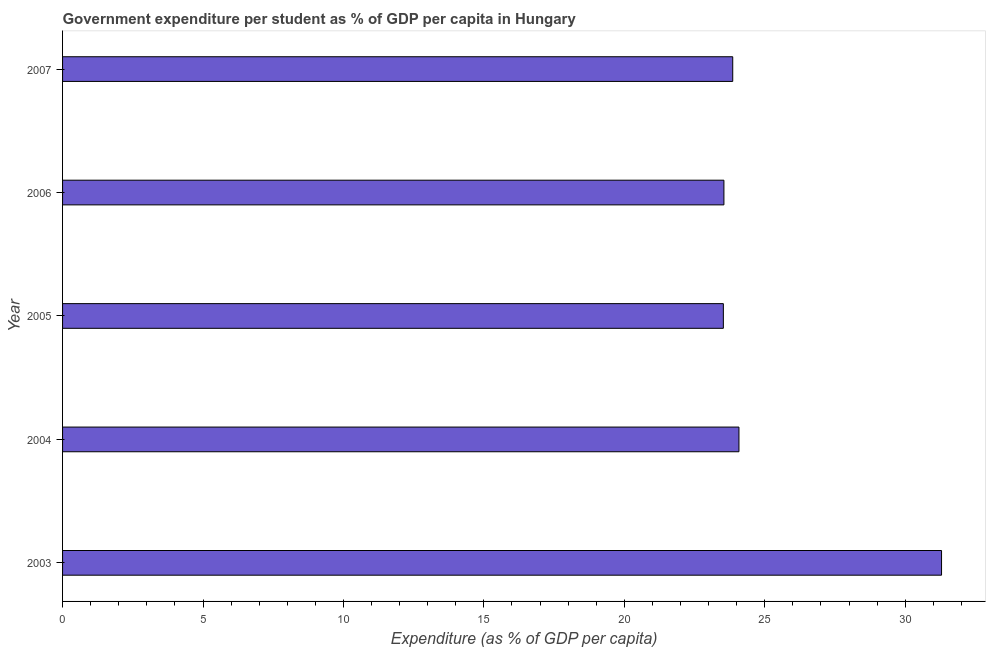What is the title of the graph?
Your answer should be compact. Government expenditure per student as % of GDP per capita in Hungary. What is the label or title of the X-axis?
Your answer should be very brief. Expenditure (as % of GDP per capita). What is the label or title of the Y-axis?
Offer a very short reply. Year. What is the government expenditure per student in 2004?
Provide a succinct answer. 24.08. Across all years, what is the maximum government expenditure per student?
Your answer should be compact. 31.29. Across all years, what is the minimum government expenditure per student?
Offer a terse response. 23.53. What is the sum of the government expenditure per student?
Offer a terse response. 126.3. What is the difference between the government expenditure per student in 2003 and 2006?
Your answer should be compact. 7.75. What is the average government expenditure per student per year?
Your answer should be compact. 25.26. What is the median government expenditure per student?
Your answer should be very brief. 23.86. In how many years, is the government expenditure per student greater than 4 %?
Make the answer very short. 5. Do a majority of the years between 2004 and 2005 (inclusive) have government expenditure per student greater than 20 %?
Provide a succinct answer. Yes. Is the government expenditure per student in 2003 less than that in 2006?
Ensure brevity in your answer.  No. What is the difference between the highest and the second highest government expenditure per student?
Provide a succinct answer. 7.21. What is the difference between the highest and the lowest government expenditure per student?
Provide a short and direct response. 7.77. How many bars are there?
Provide a short and direct response. 5. Are all the bars in the graph horizontal?
Provide a succinct answer. Yes. Are the values on the major ticks of X-axis written in scientific E-notation?
Make the answer very short. No. What is the Expenditure (as % of GDP per capita) of 2003?
Your answer should be very brief. 31.29. What is the Expenditure (as % of GDP per capita) in 2004?
Make the answer very short. 24.08. What is the Expenditure (as % of GDP per capita) of 2005?
Give a very brief answer. 23.53. What is the Expenditure (as % of GDP per capita) in 2006?
Provide a succinct answer. 23.55. What is the Expenditure (as % of GDP per capita) of 2007?
Keep it short and to the point. 23.86. What is the difference between the Expenditure (as % of GDP per capita) in 2003 and 2004?
Make the answer very short. 7.21. What is the difference between the Expenditure (as % of GDP per capita) in 2003 and 2005?
Your response must be concise. 7.77. What is the difference between the Expenditure (as % of GDP per capita) in 2003 and 2006?
Offer a very short reply. 7.75. What is the difference between the Expenditure (as % of GDP per capita) in 2003 and 2007?
Make the answer very short. 7.43. What is the difference between the Expenditure (as % of GDP per capita) in 2004 and 2005?
Ensure brevity in your answer.  0.56. What is the difference between the Expenditure (as % of GDP per capita) in 2004 and 2006?
Offer a terse response. 0.54. What is the difference between the Expenditure (as % of GDP per capita) in 2004 and 2007?
Ensure brevity in your answer.  0.22. What is the difference between the Expenditure (as % of GDP per capita) in 2005 and 2006?
Keep it short and to the point. -0.02. What is the difference between the Expenditure (as % of GDP per capita) in 2005 and 2007?
Ensure brevity in your answer.  -0.33. What is the difference between the Expenditure (as % of GDP per capita) in 2006 and 2007?
Your answer should be compact. -0.31. What is the ratio of the Expenditure (as % of GDP per capita) in 2003 to that in 2005?
Your answer should be very brief. 1.33. What is the ratio of the Expenditure (as % of GDP per capita) in 2003 to that in 2006?
Provide a succinct answer. 1.33. What is the ratio of the Expenditure (as % of GDP per capita) in 2003 to that in 2007?
Provide a succinct answer. 1.31. What is the ratio of the Expenditure (as % of GDP per capita) in 2006 to that in 2007?
Offer a very short reply. 0.99. 